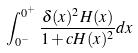Convert formula to latex. <formula><loc_0><loc_0><loc_500><loc_500>\int _ { 0 ^ { - } } ^ { 0 ^ { + } } \frac { \delta ( x ) ^ { 2 } H ( x ) } { 1 + c H ( x ) ^ { 2 } } d x</formula> 